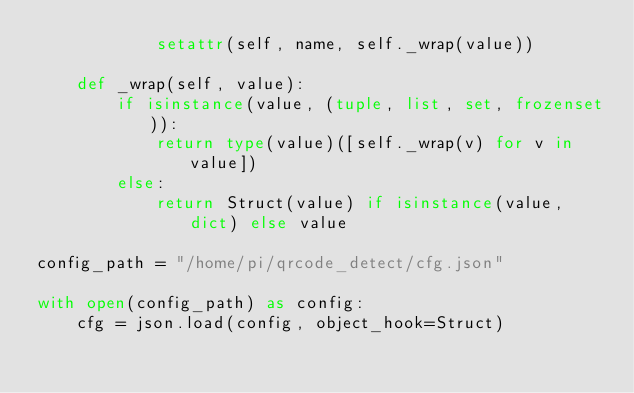Convert code to text. <code><loc_0><loc_0><loc_500><loc_500><_Python_>            setattr(self, name, self._wrap(value))

    def _wrap(self, value):
        if isinstance(value, (tuple, list, set, frozenset)):
            return type(value)([self._wrap(v) for v in value])
        else:
            return Struct(value) if isinstance(value, dict) else value

config_path = "/home/pi/qrcode_detect/cfg.json"

with open(config_path) as config:
    cfg = json.load(config, object_hook=Struct)
</code> 